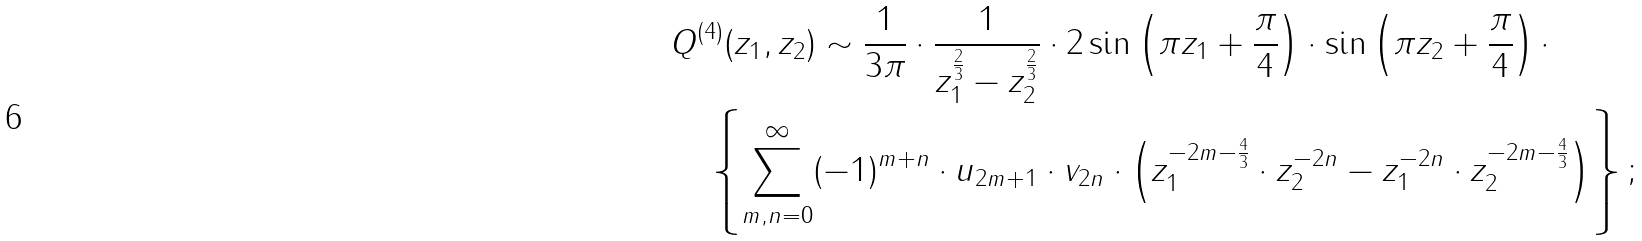<formula> <loc_0><loc_0><loc_500><loc_500>& Q ^ { ( 4 ) } ( z _ { 1 } , z _ { 2 } ) \sim \frac { 1 } { 3 \pi } \cdot \frac { 1 } { z _ { 1 } ^ { \frac { 2 } { 3 } } - z _ { 2 } ^ { \frac { 2 } { 3 } } } \cdot 2 \sin \left ( \pi z _ { 1 } + \frac { \pi } { 4 } \right ) \cdot \sin \left ( \pi z _ { 2 } + \frac { \pi } { 4 } \right ) \cdot \\ & \quad \left \{ \sum ^ { \infty } _ { m , n = 0 } ( - 1 ) ^ { m + n } \cdot u _ { 2 m + 1 } \cdot v _ { 2 n } \cdot \left ( z _ { 1 } ^ { - 2 m - \frac { 4 } { 3 } } \cdot z _ { 2 } ^ { - 2 n } - z _ { 1 } ^ { - 2 n } \cdot z _ { 2 } ^ { - 2 m - \frac { 4 } { 3 } } \right ) \right \} ;</formula> 